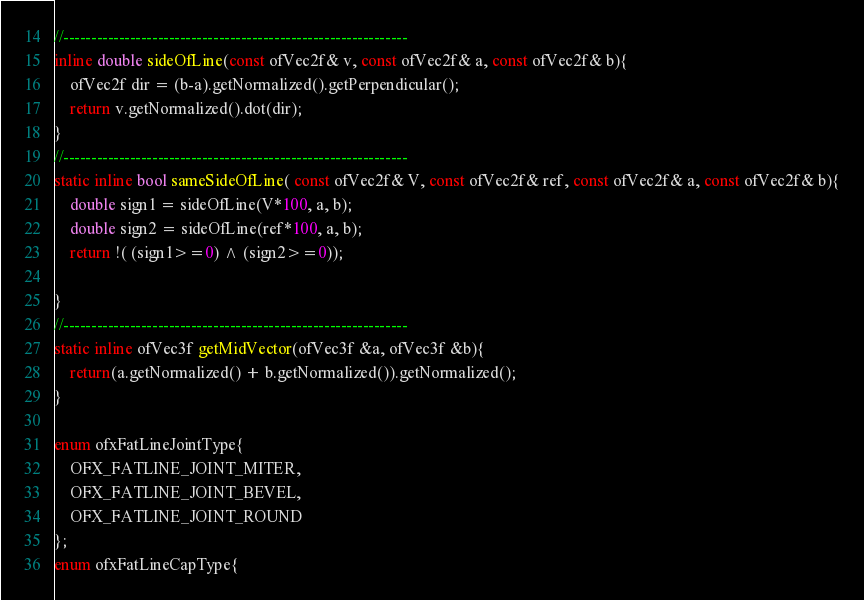<code> <loc_0><loc_0><loc_500><loc_500><_C_>//--------------------------------------------------------------
inline double sideOfLine(const ofVec2f& v, const ofVec2f& a, const ofVec2f& b){
    ofVec2f dir = (b-a).getNormalized().getPerpendicular();
    return v.getNormalized().dot(dir);
}
//--------------------------------------------------------------
static inline bool sameSideOfLine( const ofVec2f& V, const ofVec2f& ref, const ofVec2f& a, const ofVec2f& b){
	double sign1 = sideOfLine(V*100, a, b);
    double sign2 = sideOfLine(ref*100, a, b);
    return !( (sign1>=0) ^ (sign2>=0));
    
}
//--------------------------------------------------------------
static inline ofVec3f getMidVector(ofVec3f &a, ofVec3f &b){
    return(a.getNormalized() + b.getNormalized()).getNormalized();
}

enum ofxFatLineJointType{
    OFX_FATLINE_JOINT_MITER,
    OFX_FATLINE_JOINT_BEVEL,
    OFX_FATLINE_JOINT_ROUND
};
enum ofxFatLineCapType{</code> 